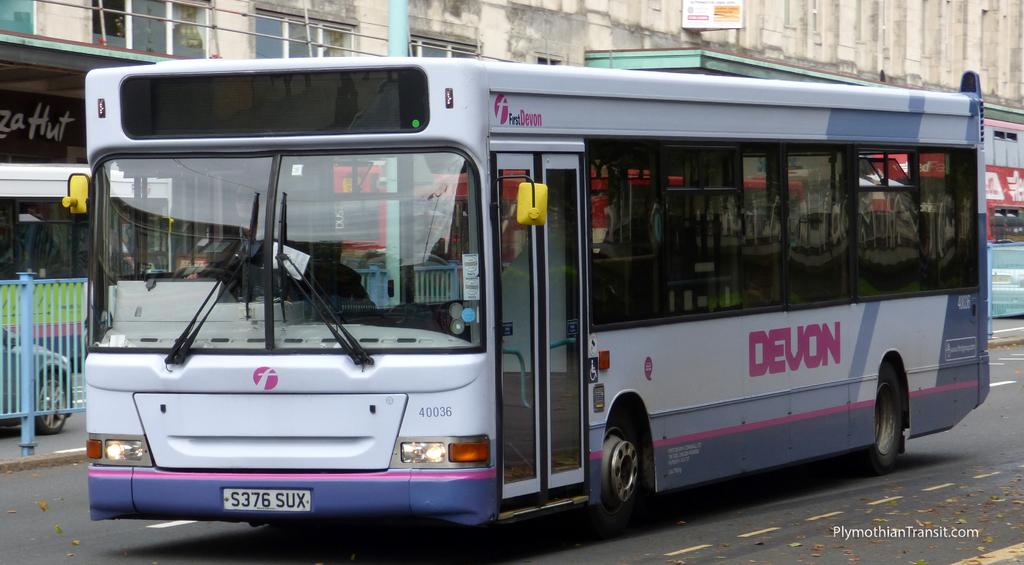What is the name on the side of the bus?
Offer a terse response. Devon. 